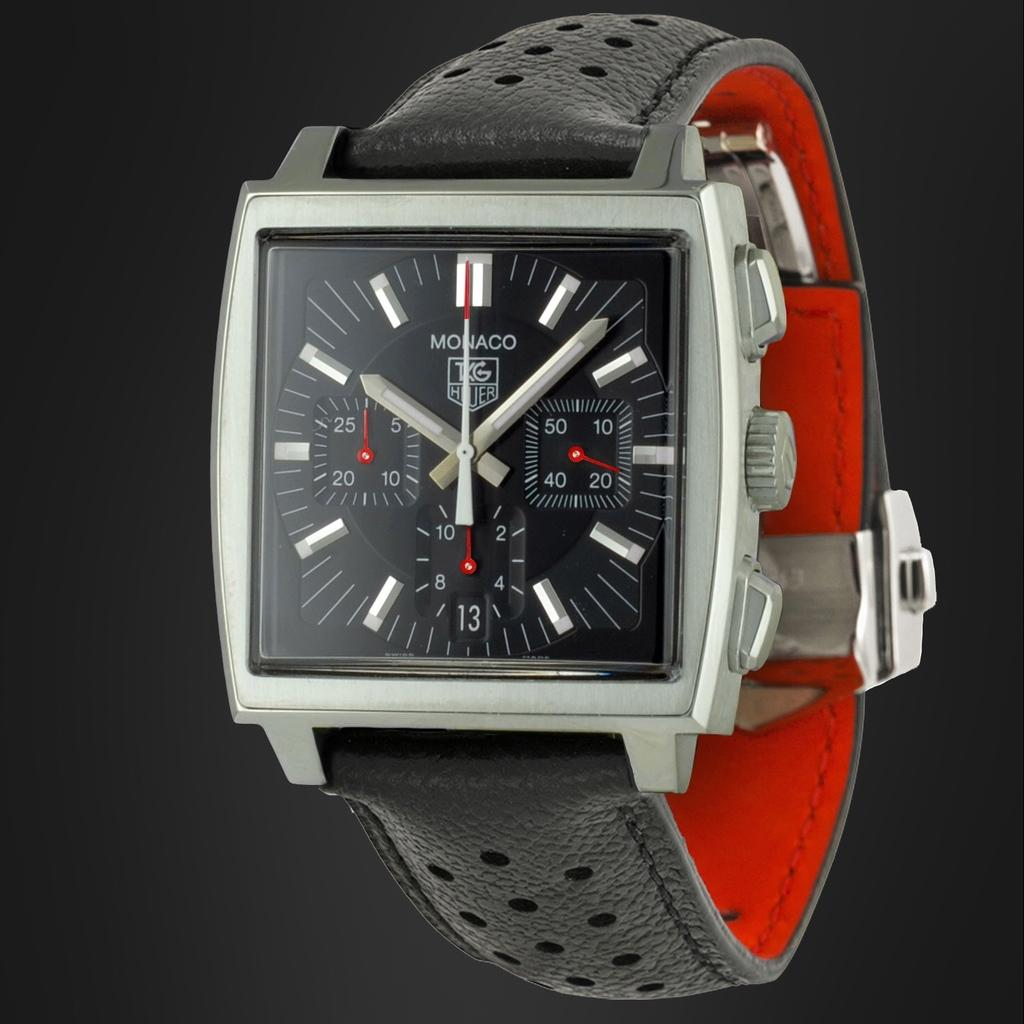Provide a one-sentence caption for the provided image. A square-faced Monaco watch in black and red. 